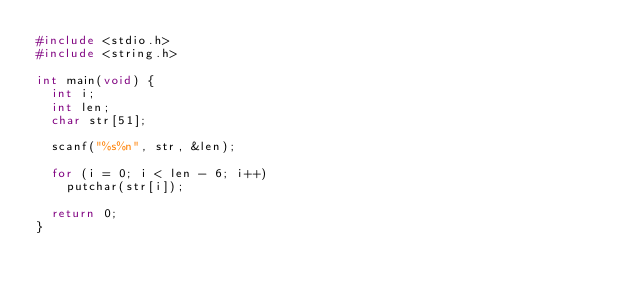Convert code to text. <code><loc_0><loc_0><loc_500><loc_500><_C_>#include <stdio.h>
#include <string.h>

int main(void) {
	int i;
	int len;
	char str[51];

	scanf("%s%n", str, &len);

	for (i = 0; i < len - 6; i++)
		putchar(str[i]);

	return 0;
}
</code> 